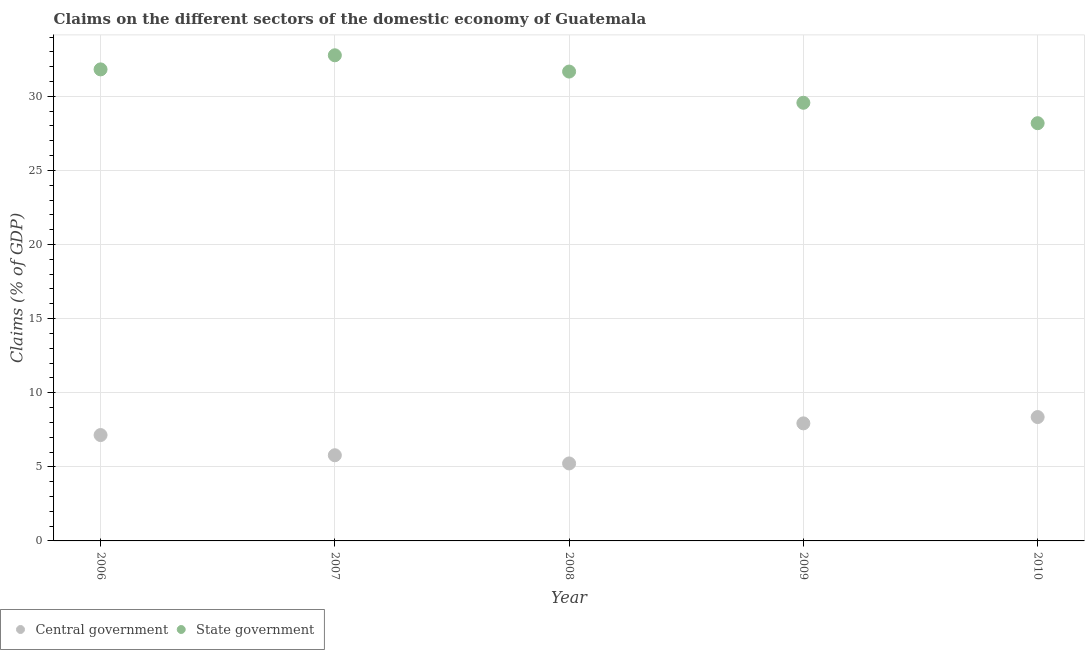What is the claims on central government in 2007?
Provide a succinct answer. 5.78. Across all years, what is the maximum claims on central government?
Your response must be concise. 8.36. Across all years, what is the minimum claims on central government?
Your response must be concise. 5.23. In which year was the claims on state government minimum?
Your answer should be compact. 2010. What is the total claims on central government in the graph?
Offer a very short reply. 34.44. What is the difference between the claims on state government in 2006 and that in 2008?
Your answer should be very brief. 0.15. What is the difference between the claims on central government in 2006 and the claims on state government in 2008?
Provide a succinct answer. -24.53. What is the average claims on central government per year?
Keep it short and to the point. 6.89. In the year 2006, what is the difference between the claims on central government and claims on state government?
Give a very brief answer. -24.67. What is the ratio of the claims on central government in 2006 to that in 2009?
Keep it short and to the point. 0.9. Is the claims on central government in 2007 less than that in 2008?
Offer a terse response. No. What is the difference between the highest and the second highest claims on state government?
Give a very brief answer. 0.95. What is the difference between the highest and the lowest claims on central government?
Your response must be concise. 3.13. In how many years, is the claims on state government greater than the average claims on state government taken over all years?
Make the answer very short. 3. Is the sum of the claims on central government in 2007 and 2009 greater than the maximum claims on state government across all years?
Your answer should be compact. No. Is the claims on central government strictly greater than the claims on state government over the years?
Provide a succinct answer. No. How many years are there in the graph?
Offer a terse response. 5. Are the values on the major ticks of Y-axis written in scientific E-notation?
Your response must be concise. No. What is the title of the graph?
Offer a very short reply. Claims on the different sectors of the domestic economy of Guatemala. Does "Broad money growth" appear as one of the legend labels in the graph?
Your response must be concise. No. What is the label or title of the Y-axis?
Give a very brief answer. Claims (% of GDP). What is the Claims (% of GDP) of Central government in 2006?
Offer a terse response. 7.14. What is the Claims (% of GDP) in State government in 2006?
Your answer should be compact. 31.82. What is the Claims (% of GDP) in Central government in 2007?
Offer a terse response. 5.78. What is the Claims (% of GDP) of State government in 2007?
Your answer should be compact. 32.77. What is the Claims (% of GDP) of Central government in 2008?
Your answer should be compact. 5.23. What is the Claims (% of GDP) of State government in 2008?
Keep it short and to the point. 31.67. What is the Claims (% of GDP) of Central government in 2009?
Provide a short and direct response. 7.93. What is the Claims (% of GDP) in State government in 2009?
Make the answer very short. 29.57. What is the Claims (% of GDP) of Central government in 2010?
Make the answer very short. 8.36. What is the Claims (% of GDP) in State government in 2010?
Offer a terse response. 28.19. Across all years, what is the maximum Claims (% of GDP) of Central government?
Give a very brief answer. 8.36. Across all years, what is the maximum Claims (% of GDP) in State government?
Give a very brief answer. 32.77. Across all years, what is the minimum Claims (% of GDP) of Central government?
Ensure brevity in your answer.  5.23. Across all years, what is the minimum Claims (% of GDP) in State government?
Offer a very short reply. 28.19. What is the total Claims (% of GDP) of Central government in the graph?
Offer a terse response. 34.44. What is the total Claims (% of GDP) in State government in the graph?
Offer a terse response. 154.02. What is the difference between the Claims (% of GDP) in Central government in 2006 and that in 2007?
Your answer should be very brief. 1.36. What is the difference between the Claims (% of GDP) of State government in 2006 and that in 2007?
Offer a terse response. -0.95. What is the difference between the Claims (% of GDP) in Central government in 2006 and that in 2008?
Make the answer very short. 1.92. What is the difference between the Claims (% of GDP) in State government in 2006 and that in 2008?
Your answer should be compact. 0.15. What is the difference between the Claims (% of GDP) of Central government in 2006 and that in 2009?
Give a very brief answer. -0.79. What is the difference between the Claims (% of GDP) in State government in 2006 and that in 2009?
Your answer should be very brief. 2.25. What is the difference between the Claims (% of GDP) of Central government in 2006 and that in 2010?
Give a very brief answer. -1.21. What is the difference between the Claims (% of GDP) of State government in 2006 and that in 2010?
Offer a very short reply. 3.63. What is the difference between the Claims (% of GDP) in Central government in 2007 and that in 2008?
Your answer should be compact. 0.55. What is the difference between the Claims (% of GDP) in State government in 2007 and that in 2008?
Your answer should be compact. 1.1. What is the difference between the Claims (% of GDP) in Central government in 2007 and that in 2009?
Your answer should be very brief. -2.15. What is the difference between the Claims (% of GDP) of State government in 2007 and that in 2009?
Make the answer very short. 3.2. What is the difference between the Claims (% of GDP) in Central government in 2007 and that in 2010?
Provide a succinct answer. -2.58. What is the difference between the Claims (% of GDP) in State government in 2007 and that in 2010?
Provide a succinct answer. 4.58. What is the difference between the Claims (% of GDP) of Central government in 2008 and that in 2009?
Keep it short and to the point. -2.7. What is the difference between the Claims (% of GDP) in State government in 2008 and that in 2009?
Offer a terse response. 2.11. What is the difference between the Claims (% of GDP) of Central government in 2008 and that in 2010?
Your answer should be compact. -3.13. What is the difference between the Claims (% of GDP) in State government in 2008 and that in 2010?
Your answer should be compact. 3.48. What is the difference between the Claims (% of GDP) in Central government in 2009 and that in 2010?
Provide a short and direct response. -0.43. What is the difference between the Claims (% of GDP) of State government in 2009 and that in 2010?
Your response must be concise. 1.38. What is the difference between the Claims (% of GDP) of Central government in 2006 and the Claims (% of GDP) of State government in 2007?
Offer a very short reply. -25.63. What is the difference between the Claims (% of GDP) in Central government in 2006 and the Claims (% of GDP) in State government in 2008?
Provide a succinct answer. -24.53. What is the difference between the Claims (% of GDP) of Central government in 2006 and the Claims (% of GDP) of State government in 2009?
Provide a short and direct response. -22.42. What is the difference between the Claims (% of GDP) in Central government in 2006 and the Claims (% of GDP) in State government in 2010?
Ensure brevity in your answer.  -21.04. What is the difference between the Claims (% of GDP) in Central government in 2007 and the Claims (% of GDP) in State government in 2008?
Give a very brief answer. -25.89. What is the difference between the Claims (% of GDP) of Central government in 2007 and the Claims (% of GDP) of State government in 2009?
Your answer should be compact. -23.79. What is the difference between the Claims (% of GDP) of Central government in 2007 and the Claims (% of GDP) of State government in 2010?
Give a very brief answer. -22.41. What is the difference between the Claims (% of GDP) in Central government in 2008 and the Claims (% of GDP) in State government in 2009?
Provide a succinct answer. -24.34. What is the difference between the Claims (% of GDP) of Central government in 2008 and the Claims (% of GDP) of State government in 2010?
Offer a very short reply. -22.96. What is the difference between the Claims (% of GDP) of Central government in 2009 and the Claims (% of GDP) of State government in 2010?
Keep it short and to the point. -20.26. What is the average Claims (% of GDP) in Central government per year?
Give a very brief answer. 6.89. What is the average Claims (% of GDP) in State government per year?
Provide a short and direct response. 30.8. In the year 2006, what is the difference between the Claims (% of GDP) in Central government and Claims (% of GDP) in State government?
Offer a terse response. -24.67. In the year 2007, what is the difference between the Claims (% of GDP) of Central government and Claims (% of GDP) of State government?
Offer a terse response. -26.99. In the year 2008, what is the difference between the Claims (% of GDP) of Central government and Claims (% of GDP) of State government?
Make the answer very short. -26.44. In the year 2009, what is the difference between the Claims (% of GDP) of Central government and Claims (% of GDP) of State government?
Your answer should be compact. -21.63. In the year 2010, what is the difference between the Claims (% of GDP) of Central government and Claims (% of GDP) of State government?
Provide a succinct answer. -19.83. What is the ratio of the Claims (% of GDP) of Central government in 2006 to that in 2007?
Provide a succinct answer. 1.24. What is the ratio of the Claims (% of GDP) of State government in 2006 to that in 2007?
Provide a short and direct response. 0.97. What is the ratio of the Claims (% of GDP) of Central government in 2006 to that in 2008?
Provide a short and direct response. 1.37. What is the ratio of the Claims (% of GDP) of Central government in 2006 to that in 2009?
Your answer should be compact. 0.9. What is the ratio of the Claims (% of GDP) of State government in 2006 to that in 2009?
Make the answer very short. 1.08. What is the ratio of the Claims (% of GDP) in Central government in 2006 to that in 2010?
Offer a terse response. 0.85. What is the ratio of the Claims (% of GDP) of State government in 2006 to that in 2010?
Ensure brevity in your answer.  1.13. What is the ratio of the Claims (% of GDP) of Central government in 2007 to that in 2008?
Your answer should be compact. 1.11. What is the ratio of the Claims (% of GDP) in State government in 2007 to that in 2008?
Make the answer very short. 1.03. What is the ratio of the Claims (% of GDP) of Central government in 2007 to that in 2009?
Make the answer very short. 0.73. What is the ratio of the Claims (% of GDP) in State government in 2007 to that in 2009?
Provide a succinct answer. 1.11. What is the ratio of the Claims (% of GDP) in Central government in 2007 to that in 2010?
Provide a short and direct response. 0.69. What is the ratio of the Claims (% of GDP) of State government in 2007 to that in 2010?
Offer a terse response. 1.16. What is the ratio of the Claims (% of GDP) of Central government in 2008 to that in 2009?
Your answer should be compact. 0.66. What is the ratio of the Claims (% of GDP) of State government in 2008 to that in 2009?
Your answer should be very brief. 1.07. What is the ratio of the Claims (% of GDP) of Central government in 2008 to that in 2010?
Your response must be concise. 0.63. What is the ratio of the Claims (% of GDP) of State government in 2008 to that in 2010?
Provide a succinct answer. 1.12. What is the ratio of the Claims (% of GDP) of Central government in 2009 to that in 2010?
Make the answer very short. 0.95. What is the ratio of the Claims (% of GDP) of State government in 2009 to that in 2010?
Ensure brevity in your answer.  1.05. What is the difference between the highest and the second highest Claims (% of GDP) in Central government?
Your answer should be compact. 0.43. What is the difference between the highest and the second highest Claims (% of GDP) of State government?
Your response must be concise. 0.95. What is the difference between the highest and the lowest Claims (% of GDP) of Central government?
Ensure brevity in your answer.  3.13. What is the difference between the highest and the lowest Claims (% of GDP) of State government?
Provide a succinct answer. 4.58. 